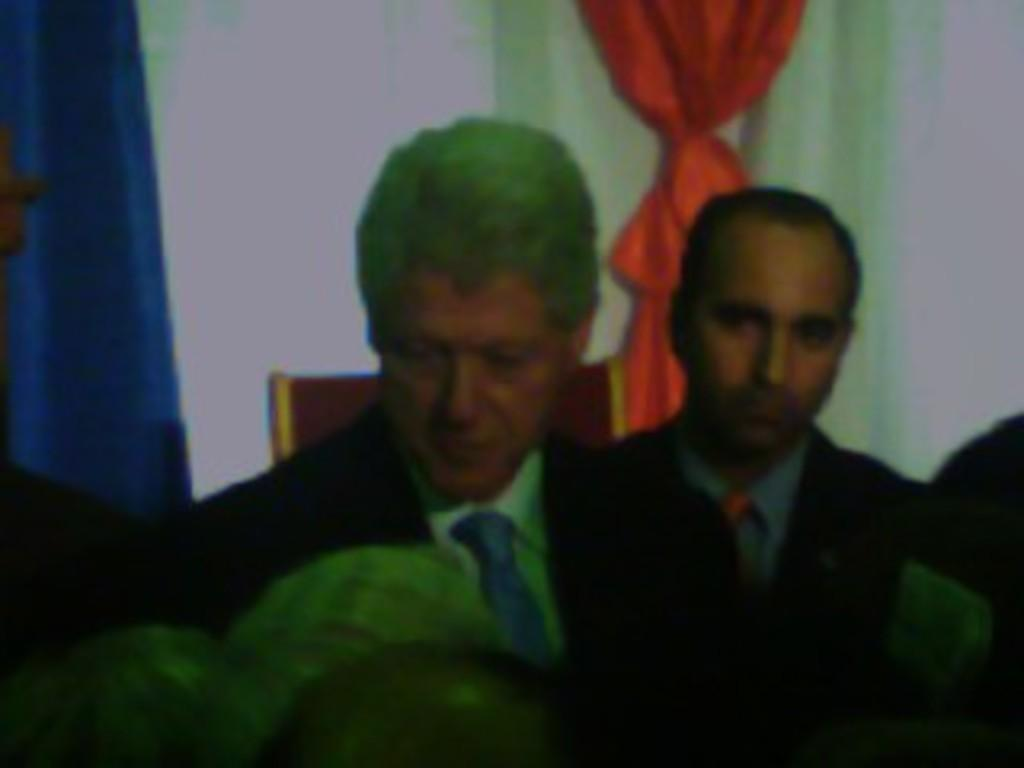How many people are present in the image? There are two men in the image. What can be seen in the background of the image? There is a wall, a chair, and a curtain in the background of the image. What type of animal can be seen in the image? There is no animal present in the image. What type of religious building is visible in the image? There is no religious building, such as a church, visible in the image. 